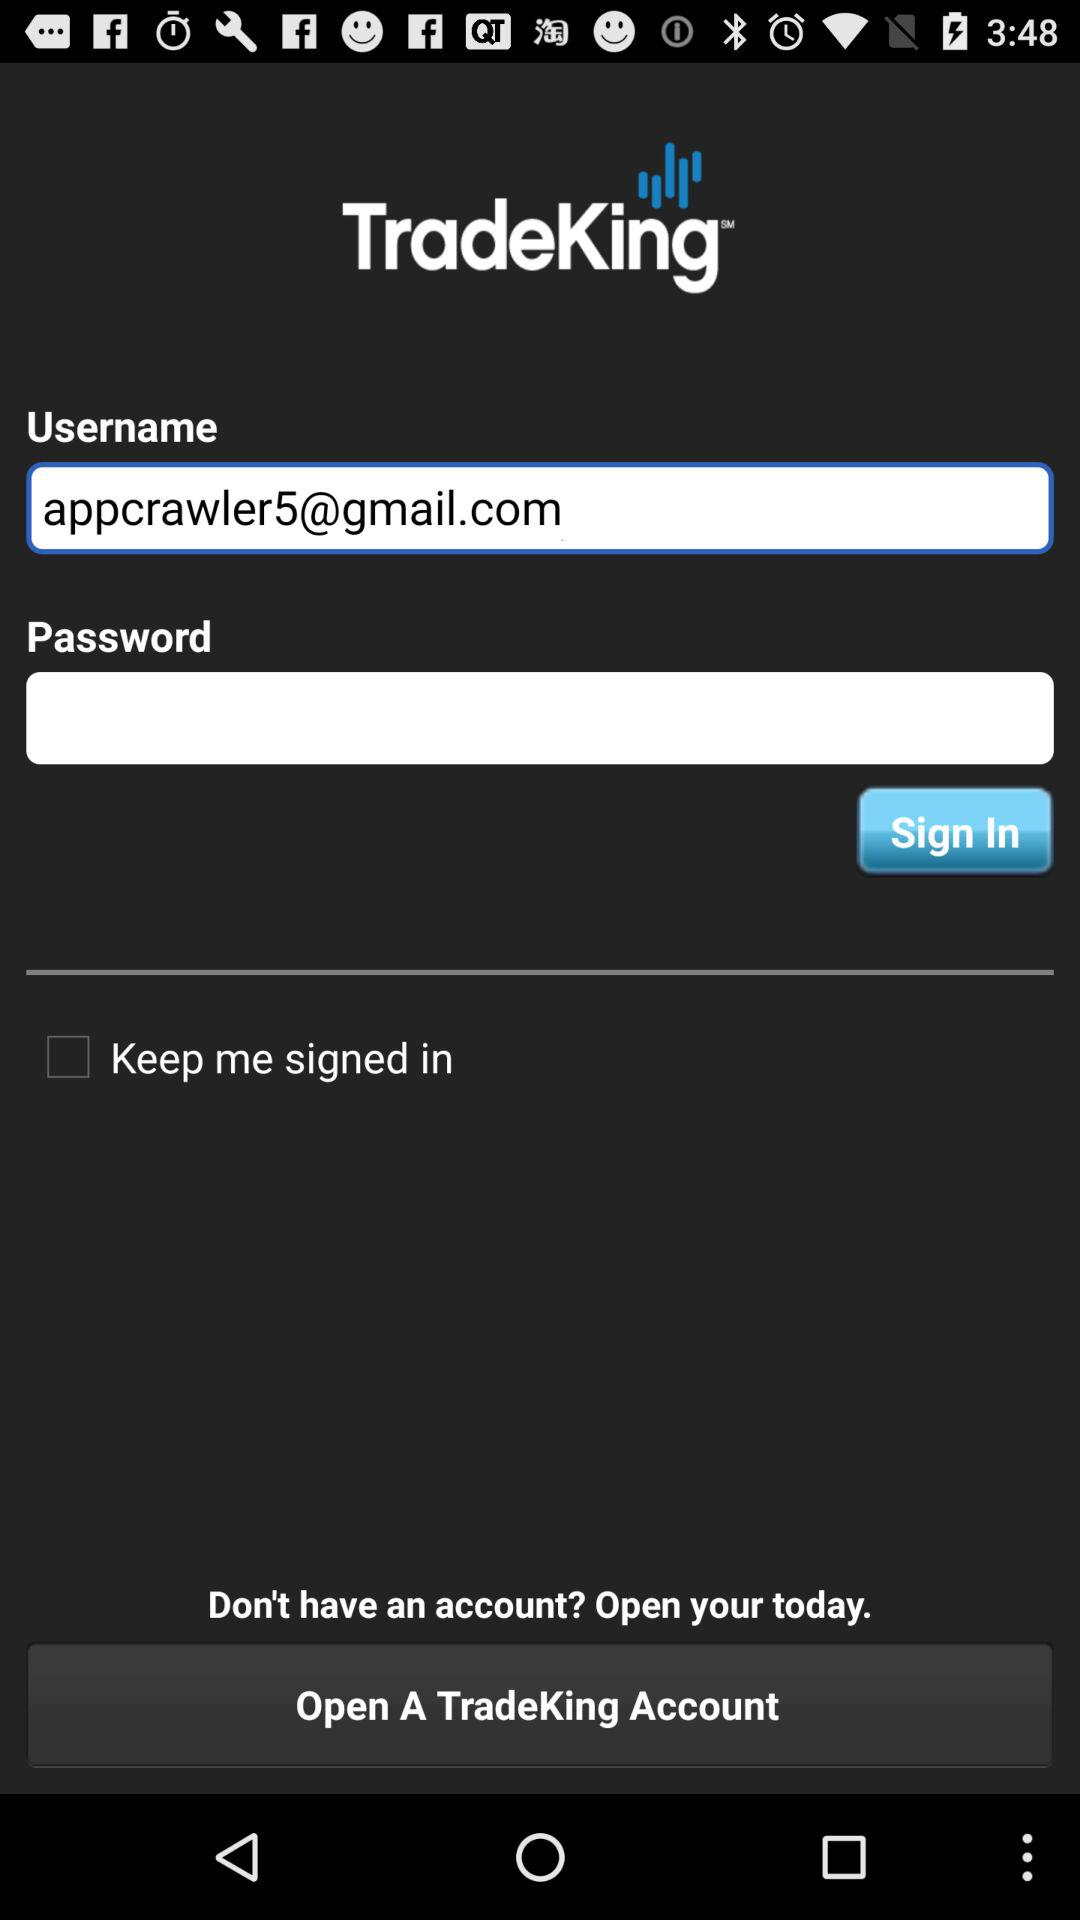What is the name of the application? The name of the application is "TradeKing". 